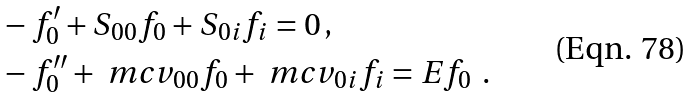Convert formula to latex. <formula><loc_0><loc_0><loc_500><loc_500>& - f _ { 0 } ^ { \prime } + S _ { 0 0 } f _ { 0 } + S _ { 0 i } f _ { i } = 0 \, , \\ & - f _ { 0 } ^ { \prime \prime } + \ m c v _ { 0 0 } f _ { 0 } + \ m c v _ { 0 i } f _ { i } = E f _ { 0 } \ \, .</formula> 